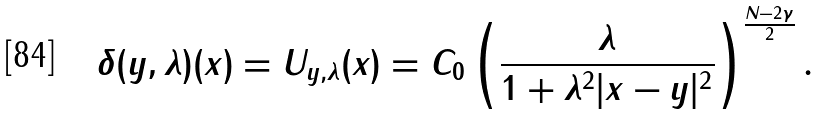Convert formula to latex. <formula><loc_0><loc_0><loc_500><loc_500>\delta ( y , \lambda ) ( x ) = U _ { y , \lambda } ( x ) = C _ { 0 } \left ( \frac { \lambda } { 1 + \lambda ^ { 2 } | x - y | ^ { 2 } } \right ) ^ { \frac { N - 2 \gamma } { 2 } } .</formula> 